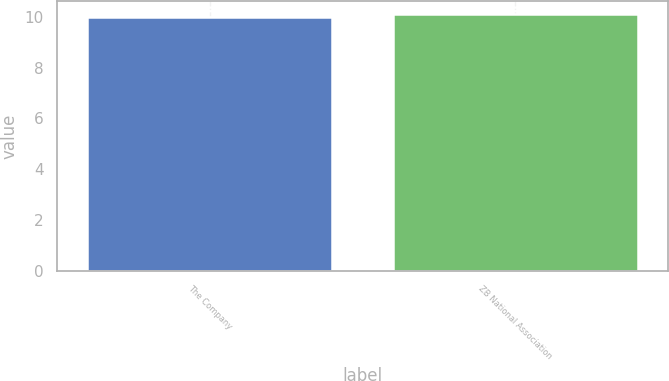Convert chart. <chart><loc_0><loc_0><loc_500><loc_500><bar_chart><fcel>The Company<fcel>ZB National Association<nl><fcel>10<fcel>10.1<nl></chart> 